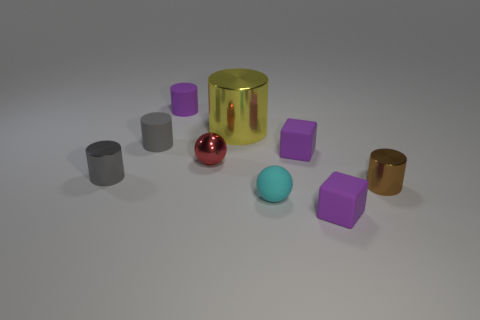Subtract all purple cylinders. How many cylinders are left? 4 Subtract all purple rubber cylinders. How many cylinders are left? 4 Subtract all red cylinders. Subtract all cyan cubes. How many cylinders are left? 5 Subtract all balls. How many objects are left? 7 Add 8 red balls. How many red balls exist? 9 Subtract 0 brown blocks. How many objects are left? 9 Subtract all large objects. Subtract all small metallic spheres. How many objects are left? 7 Add 4 purple things. How many purple things are left? 7 